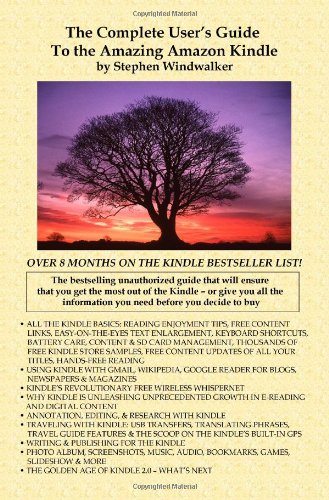What have been the critical and user receptions to this guide? The guide has been highly appreciated for its extensive and useful information, helping both first-time Kindle owners and seasoned users maximize their device's potential. Does the book include any advanced tips for troubleshooting common issues? Yes, it includes a section dedicated to troubleshooting where it outlines solutions to common problems, making it an essential tool for Kindle users. 